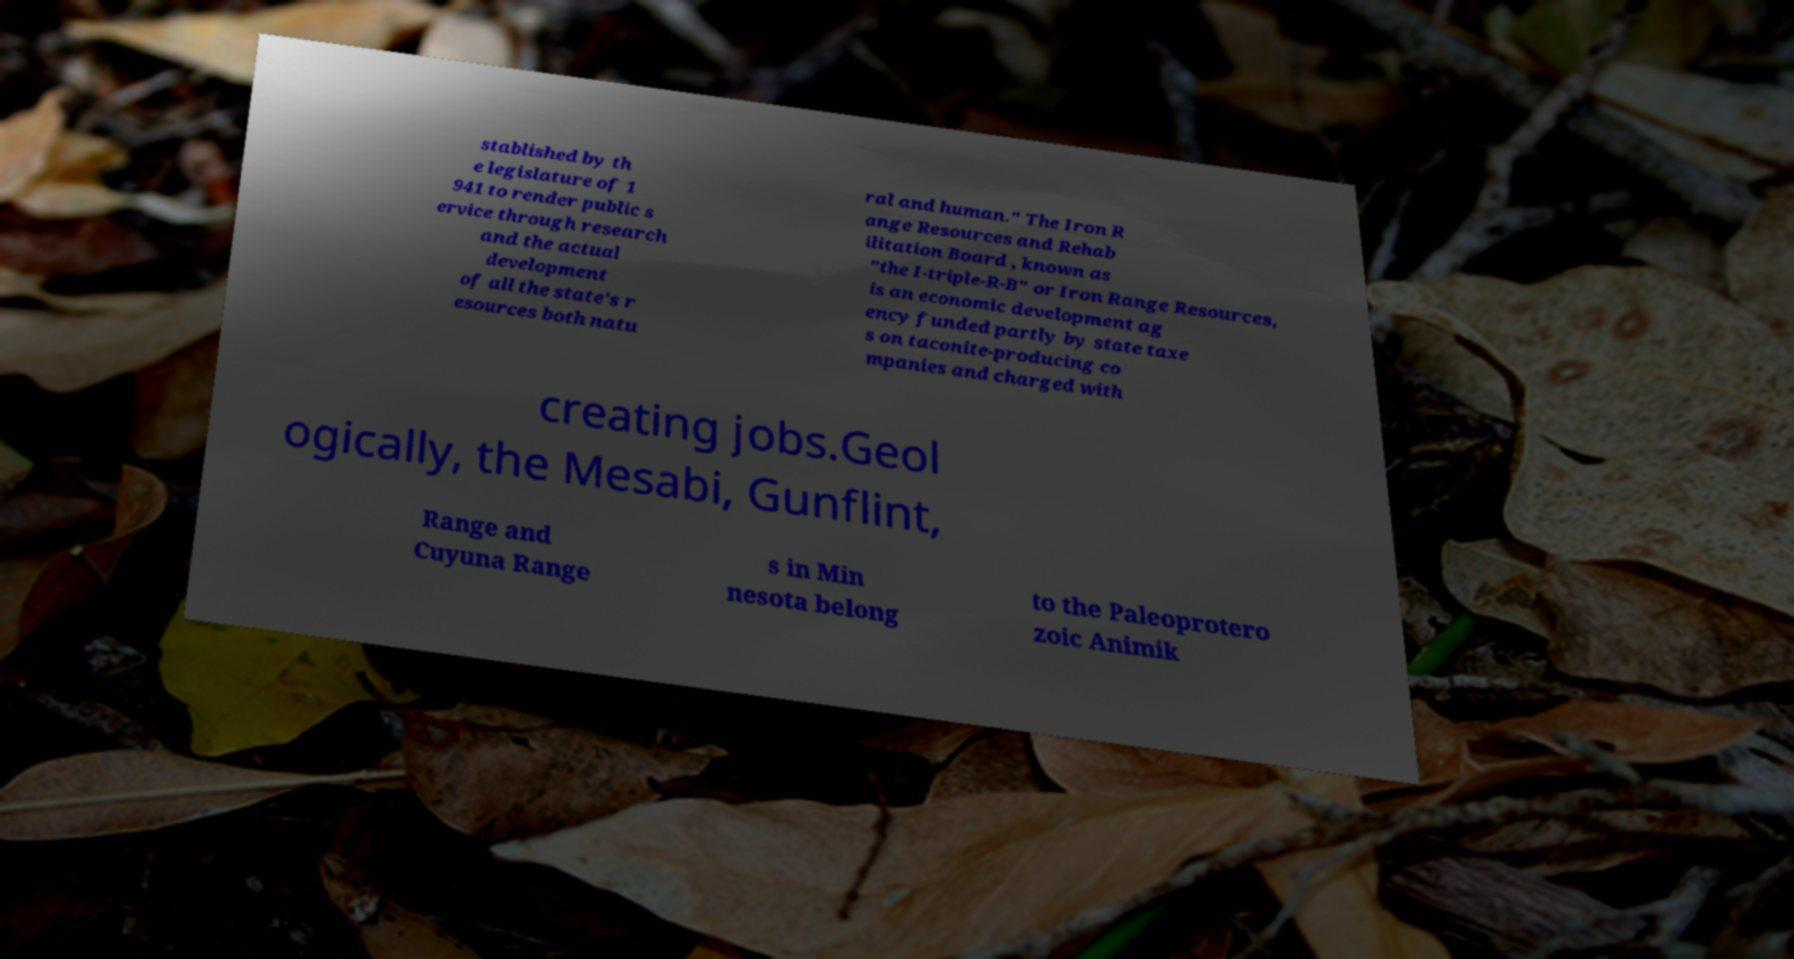What messages or text are displayed in this image? I need them in a readable, typed format. stablished by th e legislature of 1 941 to render public s ervice through research and the actual development of all the state's r esources both natu ral and human." The Iron R ange Resources and Rehab ilitation Board , known as "the I-triple-R-B" or Iron Range Resources, is an economic development ag ency funded partly by state taxe s on taconite-producing co mpanies and charged with creating jobs.Geol ogically, the Mesabi, Gunflint, Range and Cuyuna Range s in Min nesota belong to the Paleoprotero zoic Animik 